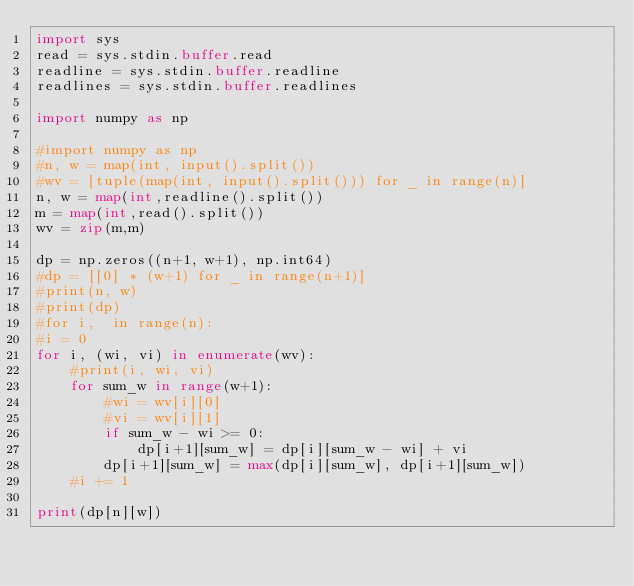<code> <loc_0><loc_0><loc_500><loc_500><_Python_>import sys
read = sys.stdin.buffer.read
readline = sys.stdin.buffer.readline
readlines = sys.stdin.buffer.readlines

import numpy as np

#import numpy as np
#n, w = map(int, input().split())
#wv = [tuple(map(int, input().split())) for _ in range(n)]
n, w = map(int,readline().split())
m = map(int,read().split())
wv = zip(m,m)

dp = np.zeros((n+1, w+1), np.int64)
#dp = [[0] * (w+1) for _ in range(n+1)]
#print(n, w)
#print(dp)
#for i,  in range(n):
#i = 0
for i, (wi, vi) in enumerate(wv):
    #print(i, wi, vi)
    for sum_w in range(w+1):
        #wi = wv[i][0]
        #vi = wv[i][1]
        if sum_w - wi >= 0:
            dp[i+1][sum_w] = dp[i][sum_w - wi] + vi
        dp[i+1][sum_w] = max(dp[i][sum_w], dp[i+1][sum_w])
    #i += 1

print(dp[n][w])</code> 